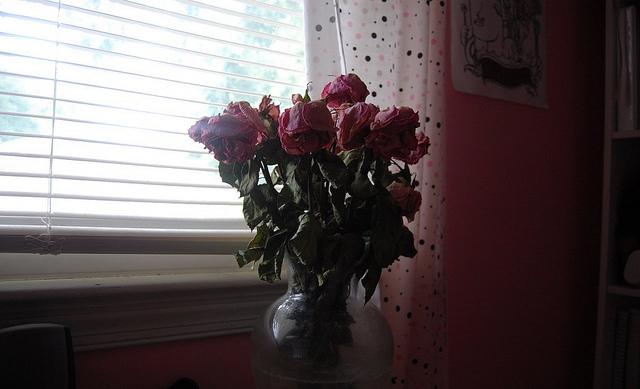Is this picture blurry?
Quick response, please. No. Do all the flowers match?
Concise answer only. Yes. Are these flowers freshly picked?
Quick response, please. No. Are these flowers dangerous to cats?
Answer briefly. No. Are the blinds closed?
Be succinct. No. What kind of flowers are in the picture?
Answer briefly. Roses. Is the window open?
Keep it brief. No. What color are the curtains in the background?
Quick response, please. White. Is there a mirror on the wall?
Write a very short answer. No. 